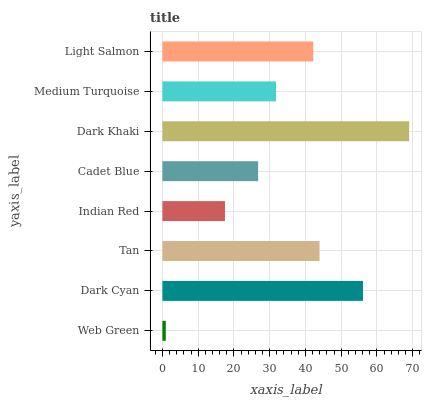Is Web Green the minimum?
Answer yes or no. Yes. Is Dark Khaki the maximum?
Answer yes or no. Yes. Is Dark Cyan the minimum?
Answer yes or no. No. Is Dark Cyan the maximum?
Answer yes or no. No. Is Dark Cyan greater than Web Green?
Answer yes or no. Yes. Is Web Green less than Dark Cyan?
Answer yes or no. Yes. Is Web Green greater than Dark Cyan?
Answer yes or no. No. Is Dark Cyan less than Web Green?
Answer yes or no. No. Is Light Salmon the high median?
Answer yes or no. Yes. Is Medium Turquoise the low median?
Answer yes or no. Yes. Is Indian Red the high median?
Answer yes or no. No. Is Light Salmon the low median?
Answer yes or no. No. 